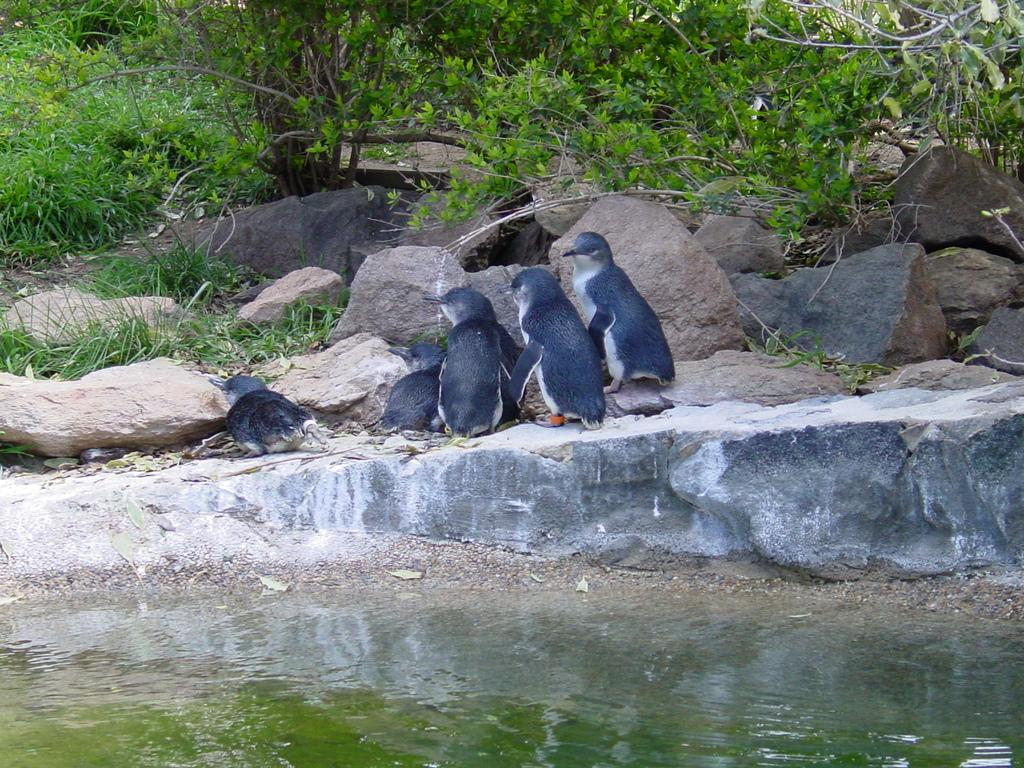What is the primary element present in the picture? There is water in the picture. What type of animals can be seen in the picture? There are penguins in the picture. What other objects or features are present in the picture? There are rocks and trees in the picture. What type of silk can be seen in the picture? There is no silk present in the picture. Is there any smoke visible in the picture? There is no smoke visible in the picture. 